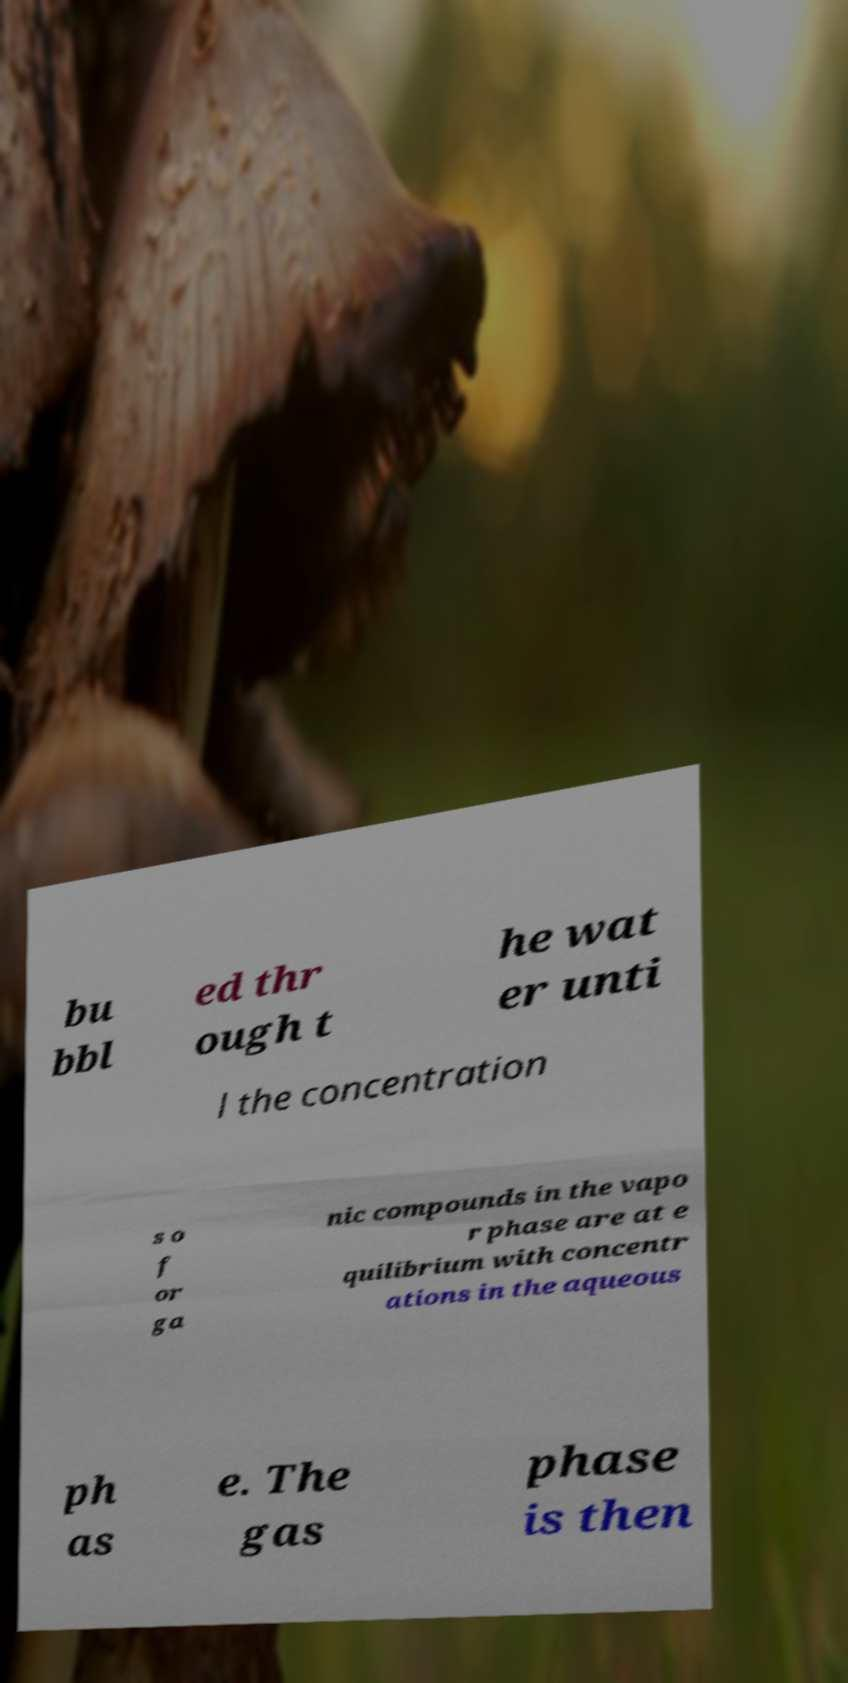There's text embedded in this image that I need extracted. Can you transcribe it verbatim? bu bbl ed thr ough t he wat er unti l the concentration s o f or ga nic compounds in the vapo r phase are at e quilibrium with concentr ations in the aqueous ph as e. The gas phase is then 